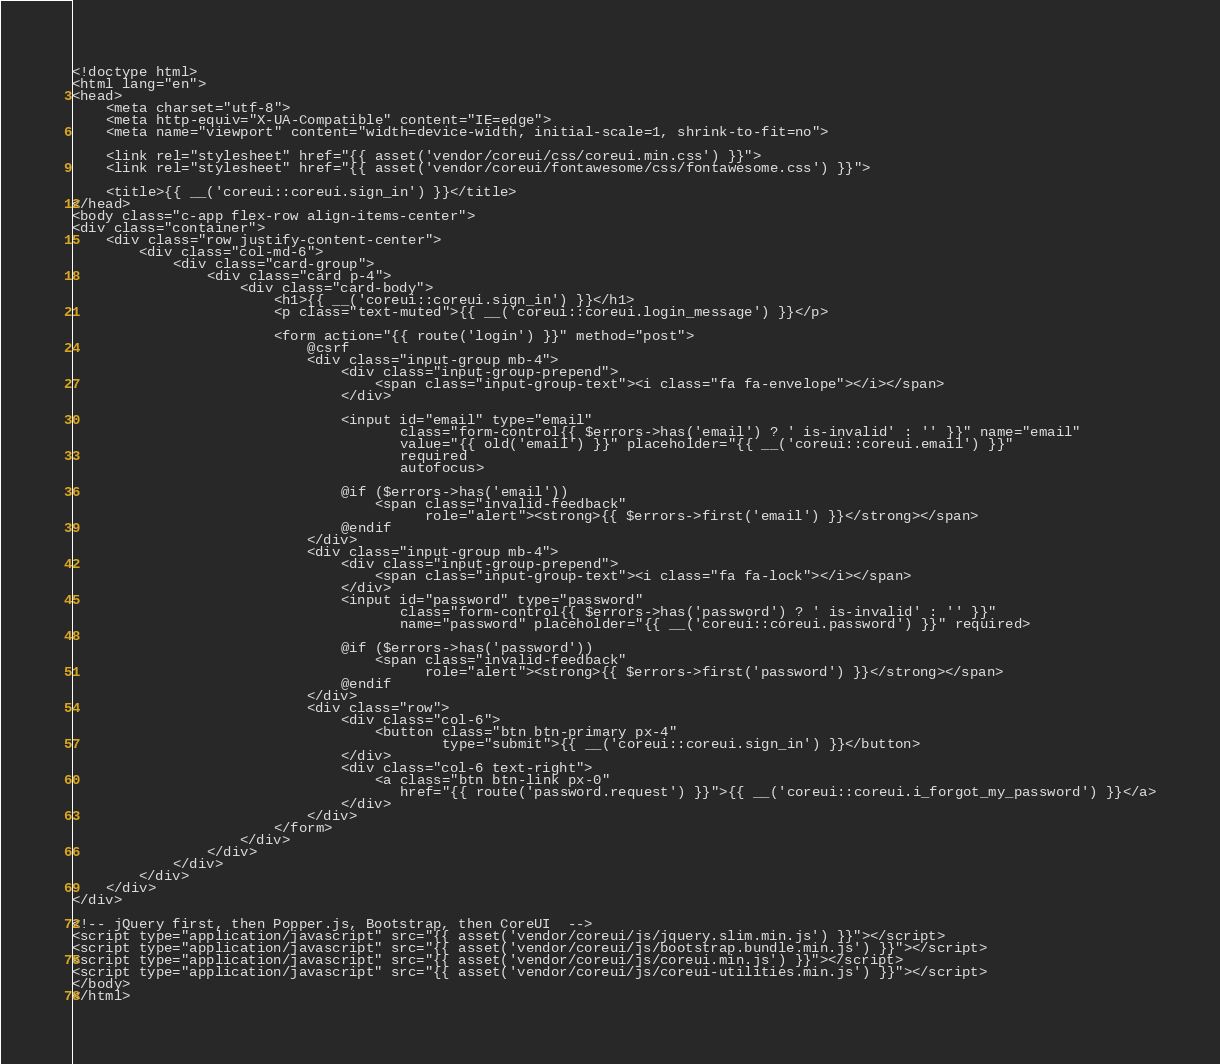<code> <loc_0><loc_0><loc_500><loc_500><_PHP_><!doctype html>
<html lang="en">
<head>
    <meta charset="utf-8">
    <meta http-equiv="X-UA-Compatible" content="IE=edge">
    <meta name="viewport" content="width=device-width, initial-scale=1, shrink-to-fit=no">

    <link rel="stylesheet" href="{{ asset('vendor/coreui/css/coreui.min.css') }}">
    <link rel="stylesheet" href="{{ asset('vendor/coreui/fontawesome/css/fontawesome.css') }}">

    <title>{{ __('coreui::coreui.sign_in') }}</title>
</head>
<body class="c-app flex-row align-items-center">
<div class="container">
    <div class="row justify-content-center">
        <div class="col-md-6">
            <div class="card-group">
                <div class="card p-4">
                    <div class="card-body">
                        <h1>{{ __('coreui::coreui.sign_in') }}</h1>
                        <p class="text-muted">{{ __('coreui::coreui.login_message') }}</p>

                        <form action="{{ route('login') }}" method="post">
                            @csrf
                            <div class="input-group mb-4">
                                <div class="input-group-prepend">
                                    <span class="input-group-text"><i class="fa fa-envelope"></i></span>
                                </div>

                                <input id="email" type="email"
                                       class="form-control{{ $errors->has('email') ? ' is-invalid' : '' }}" name="email"
                                       value="{{ old('email') }}" placeholder="{{ __('coreui::coreui.email') }}"
                                       required
                                       autofocus>

                                @if ($errors->has('email'))
                                    <span class="invalid-feedback"
                                          role="alert"><strong>{{ $errors->first('email') }}</strong></span>
                                @endif
                            </div>
                            <div class="input-group mb-4">
                                <div class="input-group-prepend">
                                    <span class="input-group-text"><i class="fa fa-lock"></i></span>
                                </div>
                                <input id="password" type="password"
                                       class="form-control{{ $errors->has('password') ? ' is-invalid' : '' }}"
                                       name="password" placeholder="{{ __('coreui::coreui.password') }}" required>

                                @if ($errors->has('password'))
                                    <span class="invalid-feedback"
                                          role="alert"><strong>{{ $errors->first('password') }}</strong></span>
                                @endif
                            </div>
                            <div class="row">
                                <div class="col-6">
                                    <button class="btn btn-primary px-4"
                                            type="submit">{{ __('coreui::coreui.sign_in') }}</button>
                                </div>
                                <div class="col-6 text-right">
                                    <a class="btn btn-link px-0"
                                       href="{{ route('password.request') }}">{{ __('coreui::coreui.i_forgot_my_password') }}</a>
                                </div>
                            </div>
                        </form>
                    </div>
                </div>
            </div>
        </div>
    </div>
</div>

<!-- jQuery first, then Popper.js, Bootstrap, then CoreUI  -->
<script type="application/javascript" src="{{ asset('vendor/coreui/js/jquery.slim.min.js') }}"></script>
<script type="application/javascript" src="{{ asset('vendor/coreui/js/bootstrap.bundle.min.js') }}"></script>
<script type="application/javascript" src="{{ asset('vendor/coreui/js/coreui.min.js') }}"></script>
<script type="application/javascript" src="{{ asset('vendor/coreui/js/coreui-utilities.min.js') }}"></script>
</body>
</html>
</code> 